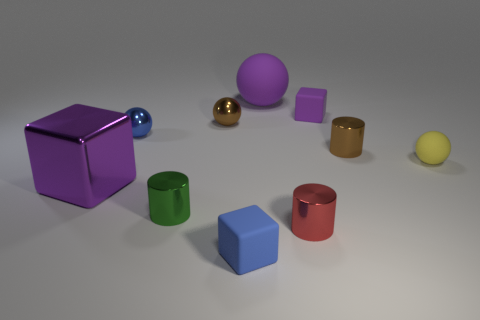Is the number of brown metallic cylinders greater than the number of blocks?
Offer a terse response. No. How many things are both in front of the brown ball and on the right side of the red thing?
Your answer should be compact. 2. What is the shape of the small blue object that is behind the shiny object left of the small blue object that is behind the yellow thing?
Provide a short and direct response. Sphere. Is there any other thing that has the same shape as the small blue rubber thing?
Your response must be concise. Yes. How many cylinders are either brown metallic things or small metallic things?
Give a very brief answer. 3. There is a tiny rubber thing that is behind the blue metal thing; is its color the same as the big ball?
Keep it short and to the point. Yes. What is the material of the tiny ball that is on the right side of the matte cube that is in front of the object on the left side of the tiny blue metal sphere?
Keep it short and to the point. Rubber. Do the purple matte sphere and the red cylinder have the same size?
Your answer should be compact. No. Does the big block have the same color as the big thing that is right of the purple metal block?
Give a very brief answer. Yes. There is a small blue object that is the same material as the tiny brown ball; what shape is it?
Ensure brevity in your answer.  Sphere. 